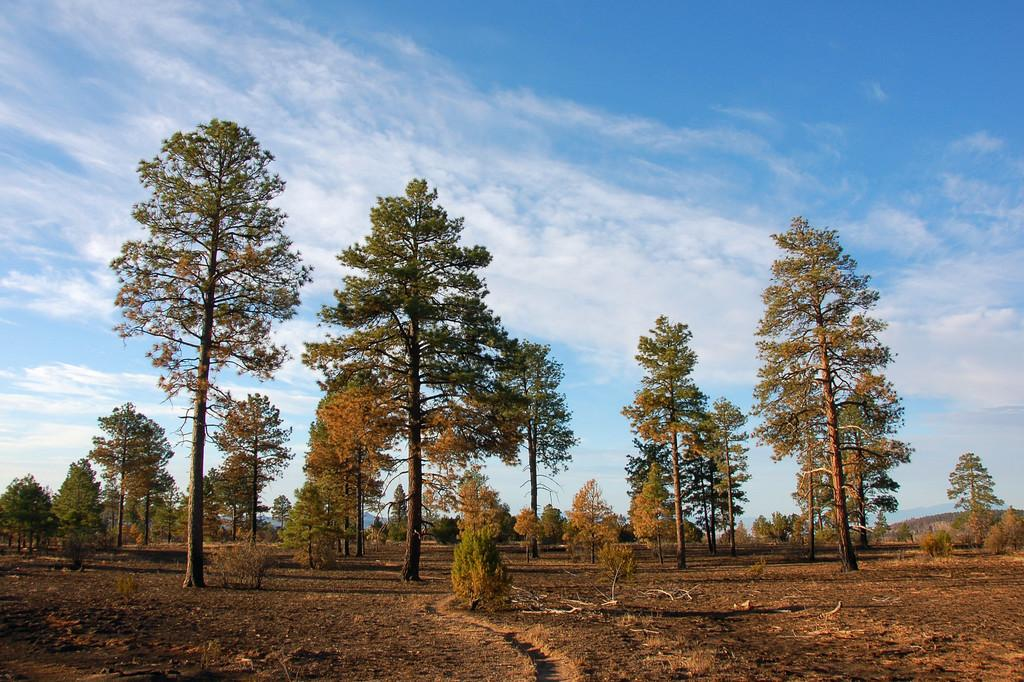What type of natural environment is depicted in the image? The image features many trees, indicating a forest or wooded area. What can be seen above the trees in the image? There is sky visible in the image. What is present in the sky in the image? Clouds are present in the sky. What type of vest can be seen hanging from a tree in the image? There is no vest present in the image; it features trees, sky, and clouds. 